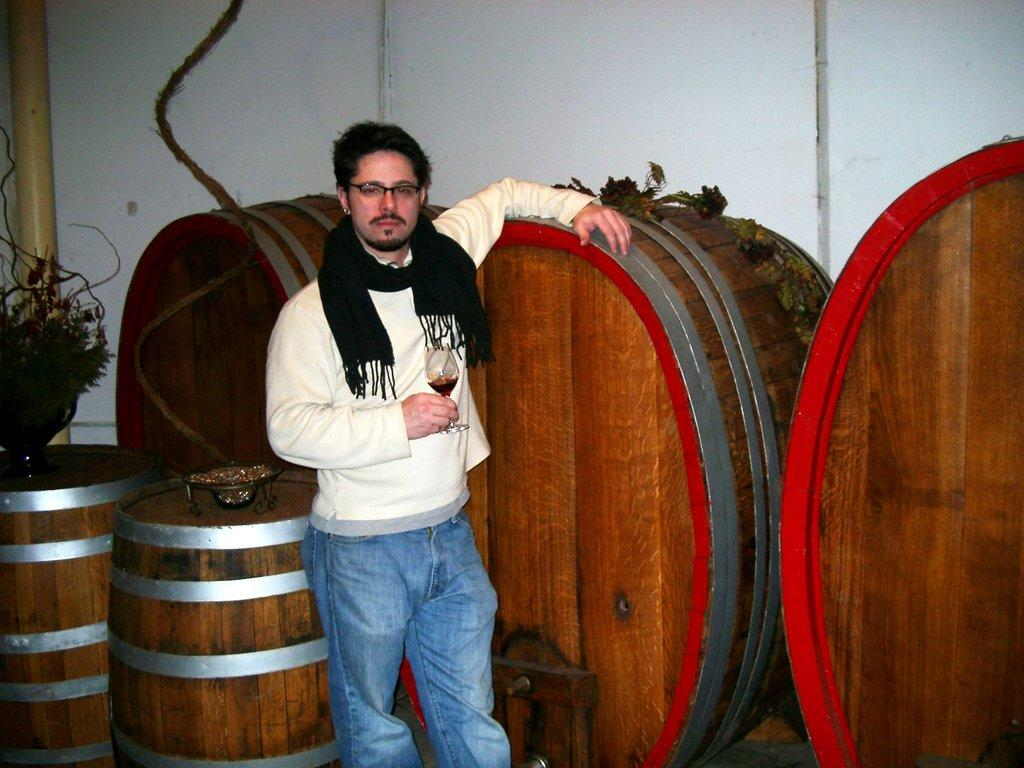What is the person in the image doing? The person is standing in the image and holding a glass. What else can be seen in the image besides the person? There are barrels, a potted plant, and other objects in the image. What is the background of the image? There is a wall in the background of the image. What type of badge is the person wearing in the image? There is no badge visible on the person in the image. What substance is being poured into the glass the person is holding? The provided facts do not mention any substance being poured into the glass, so we cannot determine what is being poured into the glass. 